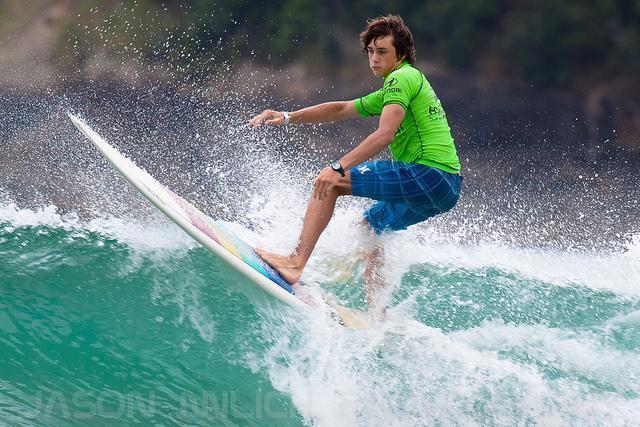How many skiiers are standing to the right of the train car?
Give a very brief answer. 0. 